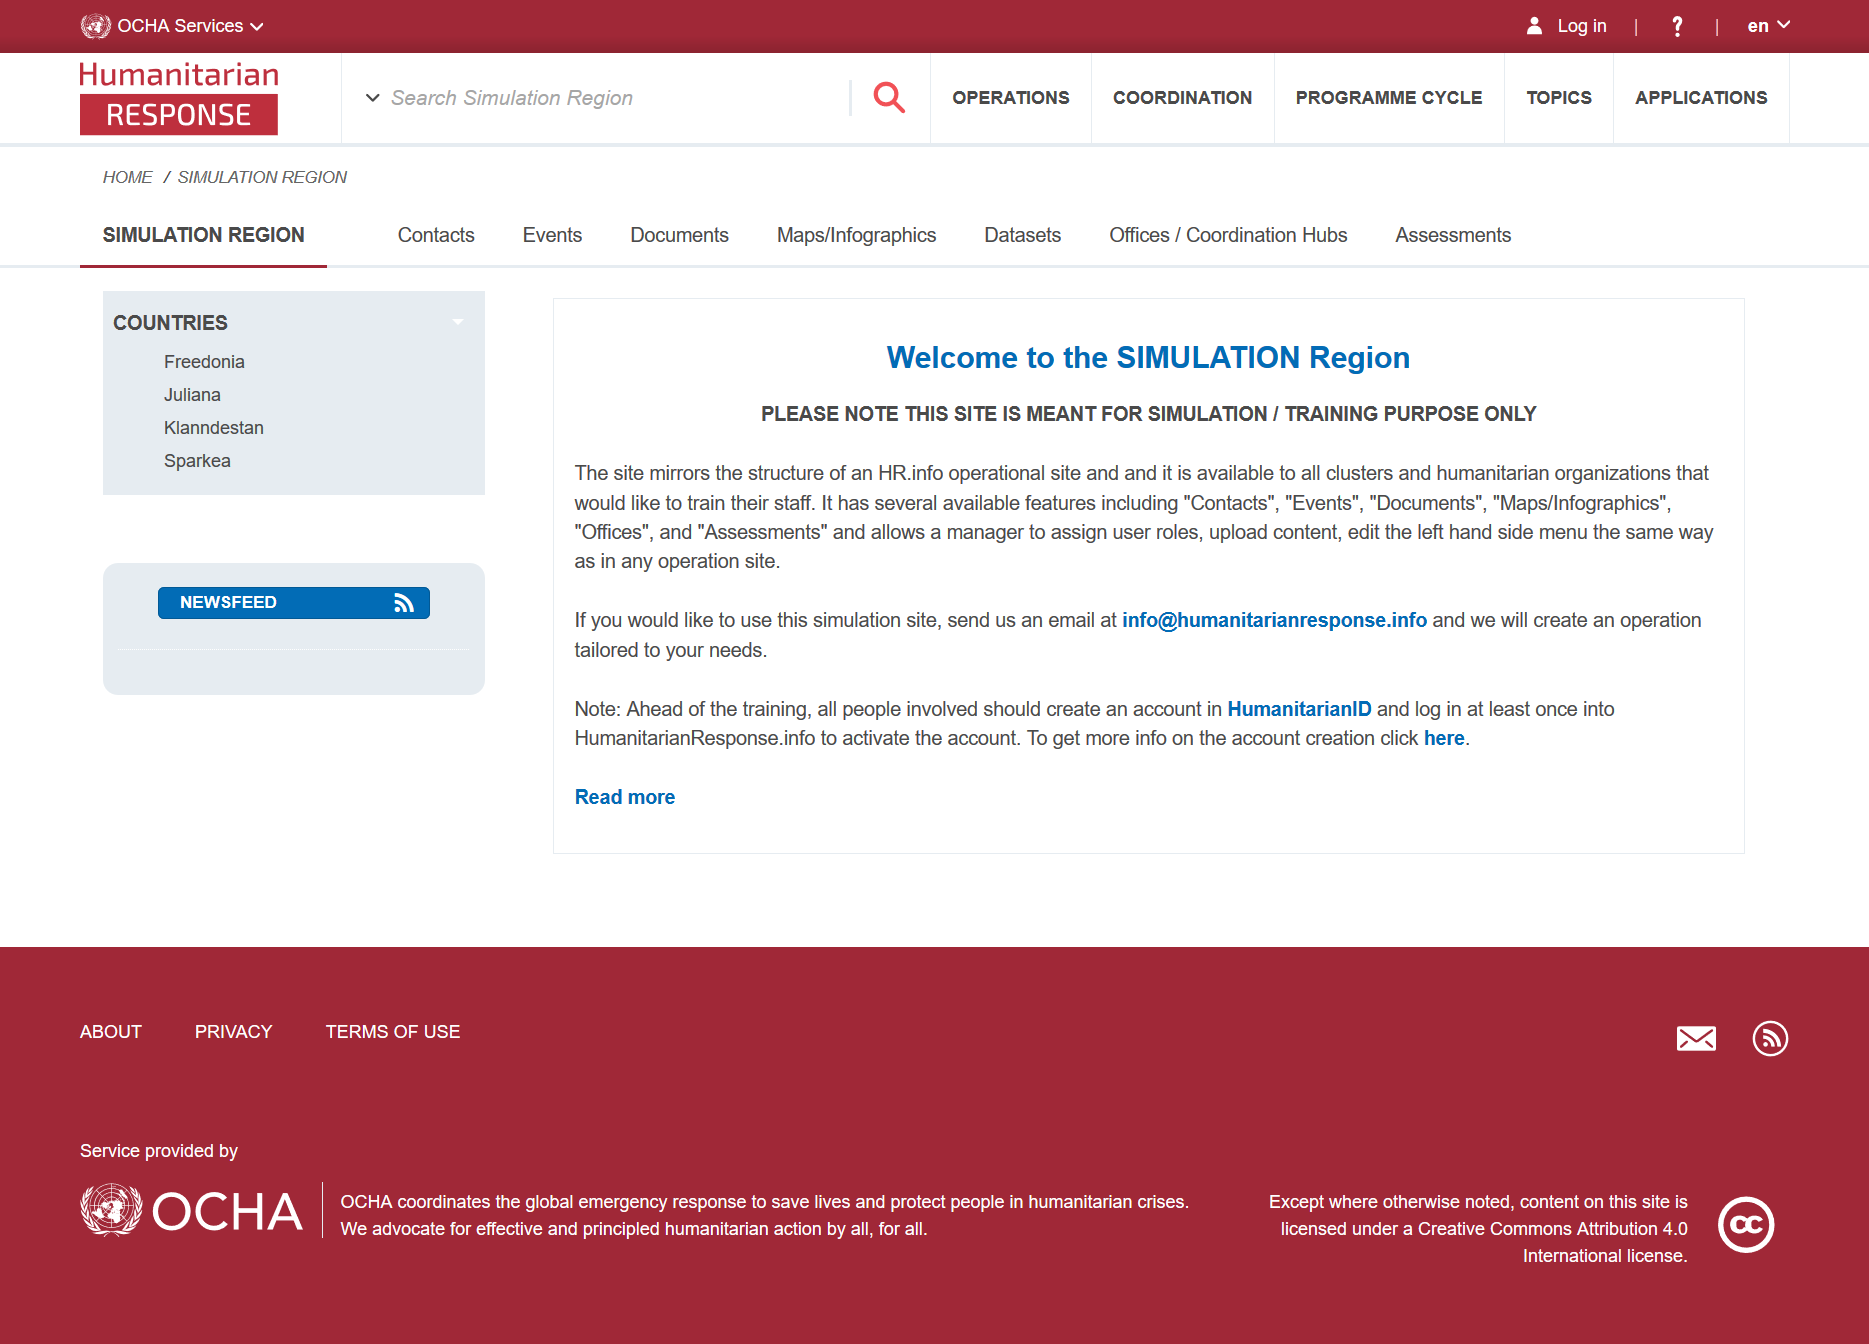Draw attention to some important aspects in this diagram. The SIMULATION Region website is structured similarly to an HR.info operational site. Contacts is a feature available on the site. The SIMULATION Region is not intended solely for simulation and training purposes, as stated in the document. 